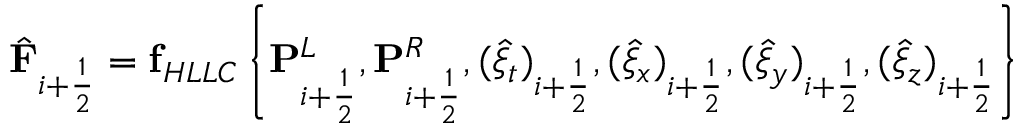<formula> <loc_0><loc_0><loc_500><loc_500>\hat { F } _ { i + \frac { 1 } { 2 } } = f _ { H L L C } \left \{ P _ { i + \frac { 1 } { 2 } } ^ { L } , P _ { i + \frac { 1 } { 2 } } ^ { R } , ( \hat { \xi } _ { t } ) _ { i + \frac { 1 } { 2 } } , ( \hat { \xi } _ { x } ) _ { i + \frac { 1 } { 2 } } , ( \hat { \xi } _ { y } ) _ { i + \frac { 1 } { 2 } } , ( \hat { \xi } _ { z } ) _ { i + \frac { 1 } { 2 } } \right \}</formula> 